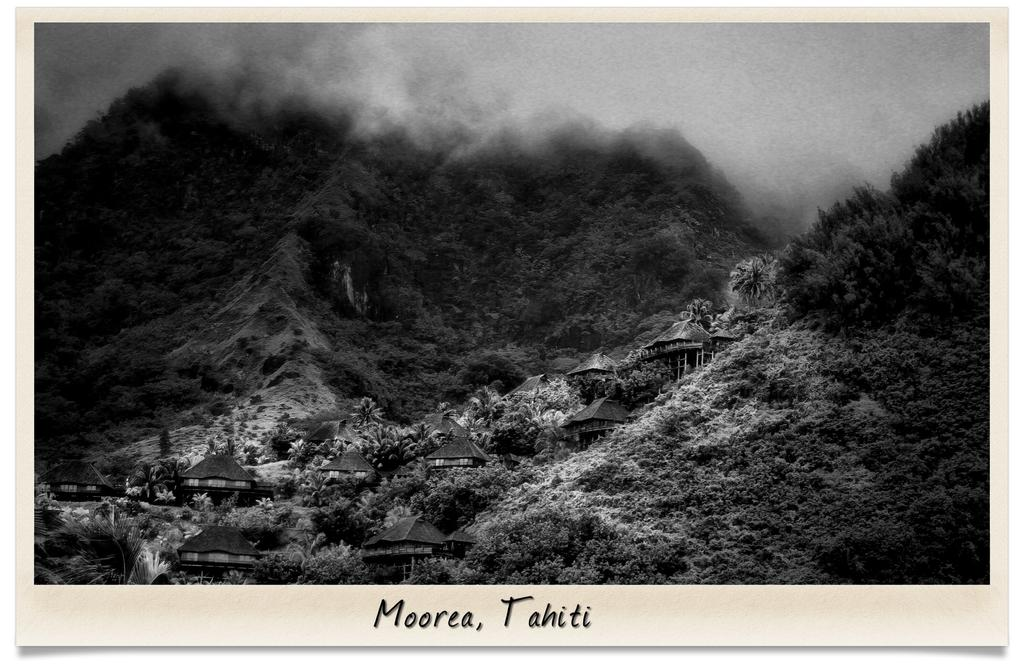What can be found at the bottom of the picture? There is some text at the bottom of the picture. What type of structures are present in the image? There are houses in the image. What other natural elements can be seen in the image? There are trees and wooden poles visible in the image. What is visible in the background of the image? There is greenery visible in the background of the image. What type of nut is being used to support the houses in the image? There is no nut present in the image; the wooden poles are supporting the houses. 